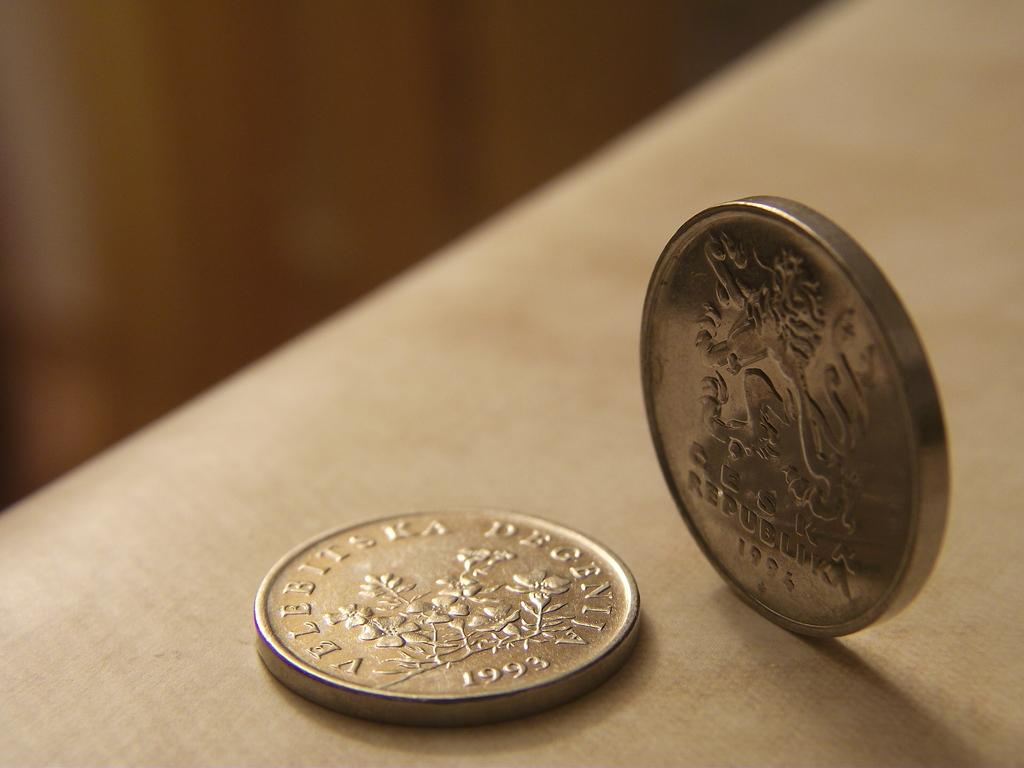<image>
Give a short and clear explanation of the subsequent image. a silver coin on a table that says 'velebitsra' on it 